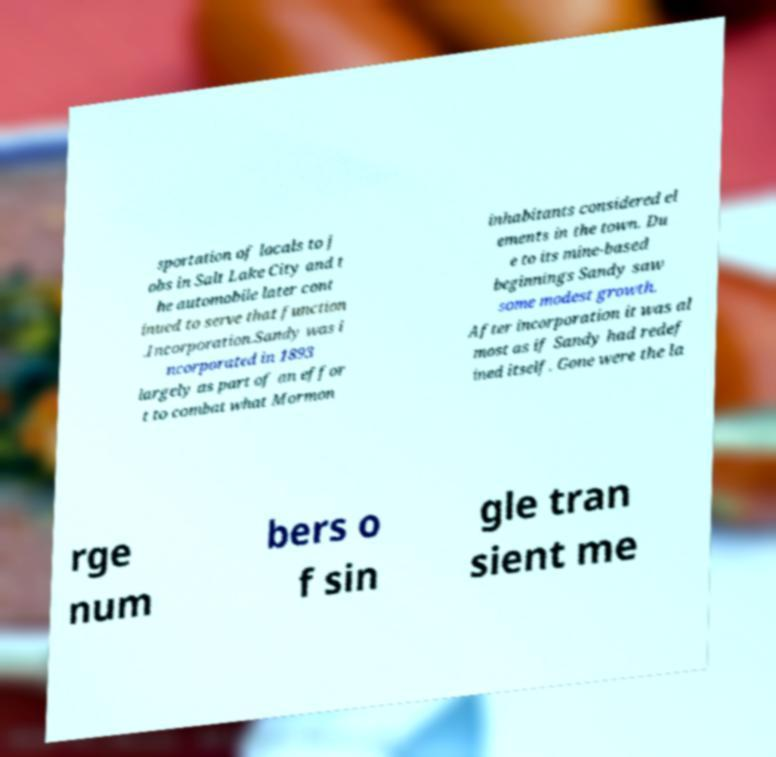What messages or text are displayed in this image? I need them in a readable, typed format. sportation of locals to j obs in Salt Lake City and t he automobile later cont inued to serve that function .Incorporation.Sandy was i ncorporated in 1893 largely as part of an effor t to combat what Mormon inhabitants considered el ements in the town. Du e to its mine-based beginnings Sandy saw some modest growth. After incorporation it was al most as if Sandy had redef ined itself. Gone were the la rge num bers o f sin gle tran sient me 